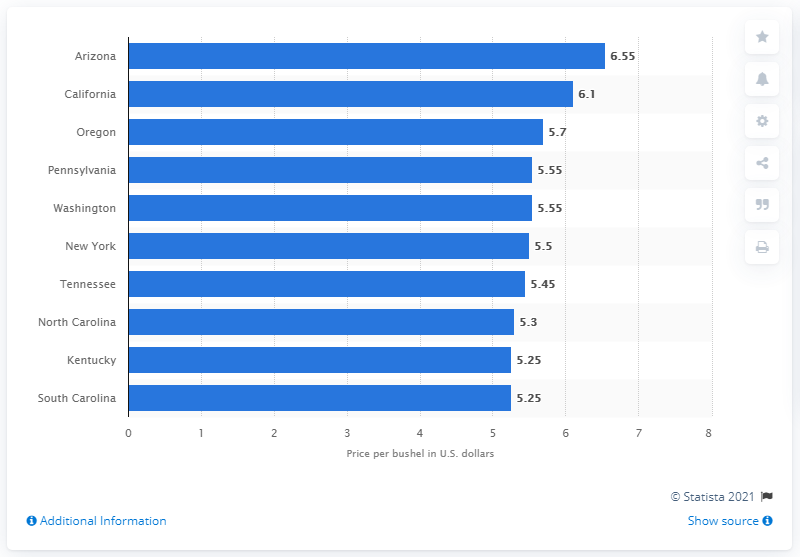Which state had the second highest average price per bushel of wheat? California had the second highest average price per bushel of wheat at $6.10. 